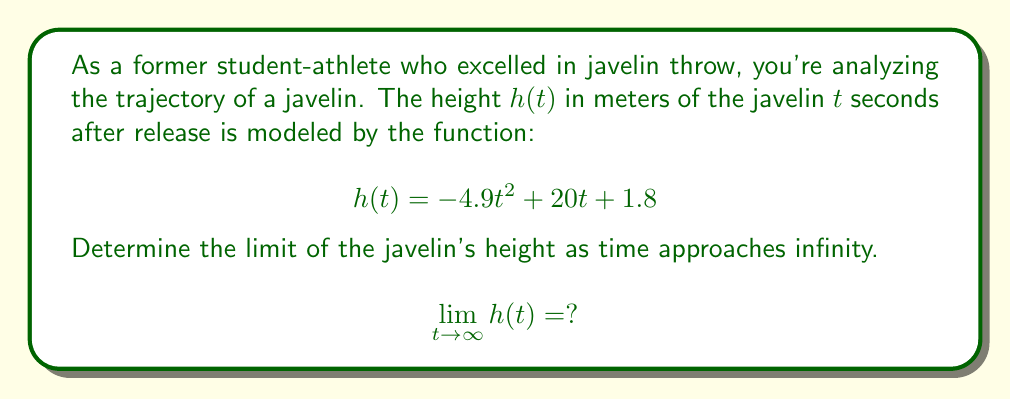Teach me how to tackle this problem. To determine the limit of $h(t)$ as $t$ approaches infinity, we need to analyze the behavior of each term in the function:

1) First, let's consider the quadratic term: $-4.9t^2$
   As $t$ approaches infinity, this term becomes negatively infinite.

2) The linear term: $20t$
   This term also grows as $t$ increases, but at a slower rate than the quadratic term.

3) The constant term: $1.8$
   This term remains constant regardless of $t$.

As $t$ approaches infinity, the quadratic term $-4.9t^2$ dominates the function. This is because it grows much faster than the linear term $20t$, and the constant term becomes negligible.

We can verify this by dividing each term by $t^2$ and taking the limit:

$$\lim_{t \to \infty} h(t) = \lim_{t \to \infty} (-4.9t^2 + 20t + 1.8)$$
$$= \lim_{t \to \infty} t^2(-4.9 + \frac{20}{t} + \frac{1.8}{t^2})$$
$$= \lim_{t \to \infty} t^2 \cdot \lim_{t \to \infty}(-4.9 + \frac{20}{t} + \frac{1.8}{t^2})$$
$$= \lim_{t \to \infty} t^2 \cdot (-4.9 + 0 + 0)$$
$$= \lim_{t \to \infty} -4.9t^2$$

Therefore, as $t$ approaches infinity, $h(t)$ approaches negative infinity.
Answer: $$\lim_{t \to \infty} h(t) = -\infty$$ 